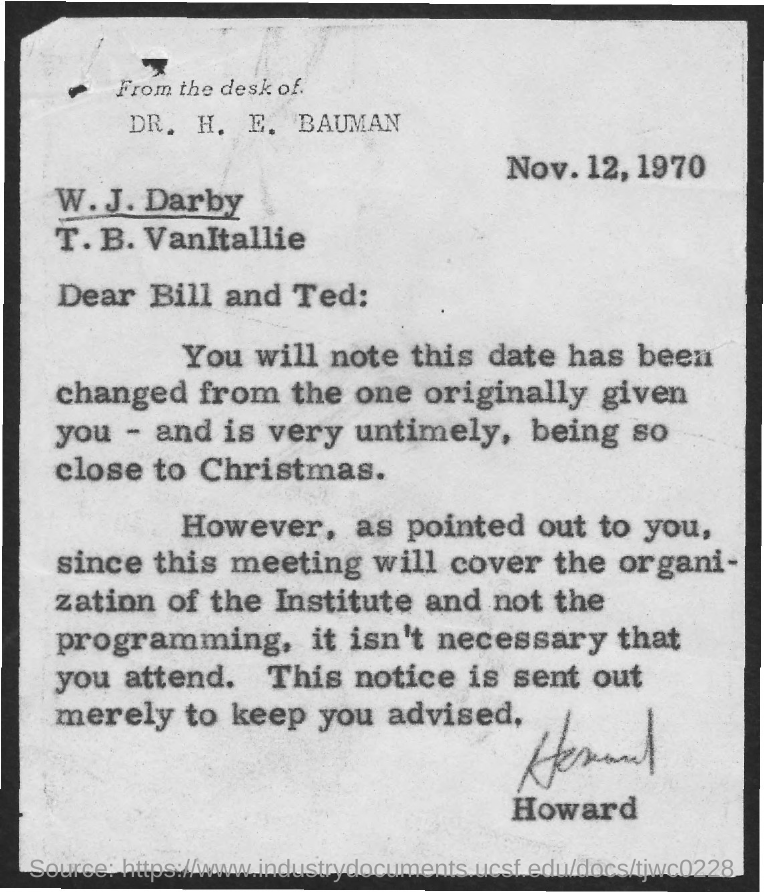Identify some key points in this picture. The date mentioned in the document is November 12, 1970. 